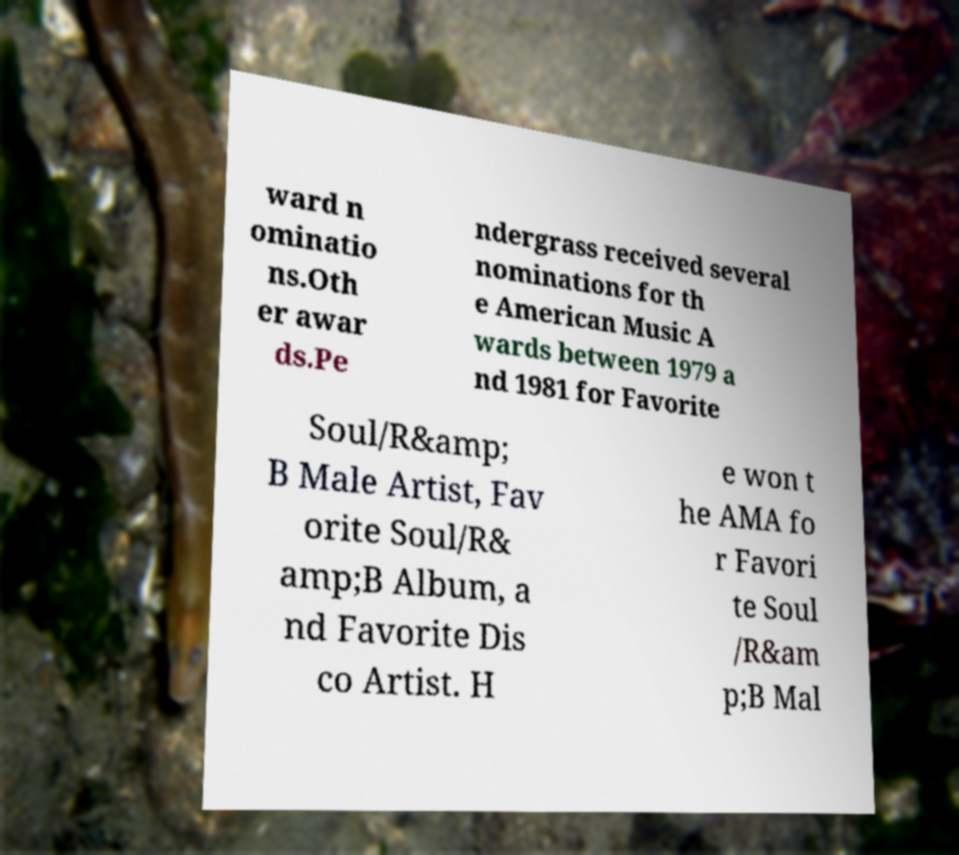I need the written content from this picture converted into text. Can you do that? ward n ominatio ns.Oth er awar ds.Pe ndergrass received several nominations for th e American Music A wards between 1979 a nd 1981 for Favorite Soul/R&amp; B Male Artist, Fav orite Soul/R& amp;B Album, a nd Favorite Dis co Artist. H e won t he AMA fo r Favori te Soul /R&am p;B Mal 